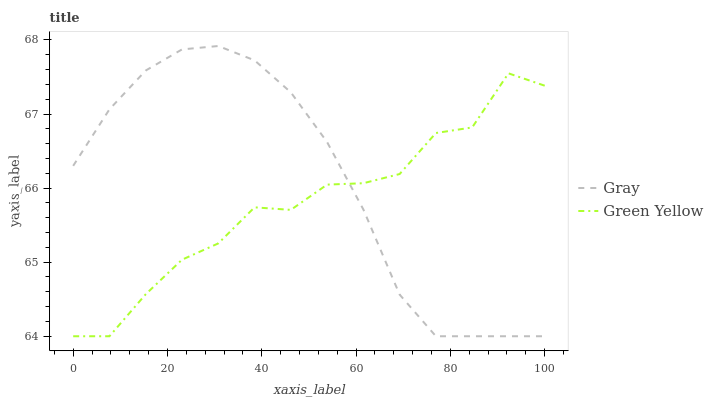Does Green Yellow have the minimum area under the curve?
Answer yes or no. Yes. Does Gray have the maximum area under the curve?
Answer yes or no. Yes. Does Green Yellow have the maximum area under the curve?
Answer yes or no. No. Is Gray the smoothest?
Answer yes or no. Yes. Is Green Yellow the roughest?
Answer yes or no. Yes. Is Green Yellow the smoothest?
Answer yes or no. No. Does Gray have the lowest value?
Answer yes or no. Yes. Does Gray have the highest value?
Answer yes or no. Yes. Does Green Yellow have the highest value?
Answer yes or no. No. Does Green Yellow intersect Gray?
Answer yes or no. Yes. Is Green Yellow less than Gray?
Answer yes or no. No. Is Green Yellow greater than Gray?
Answer yes or no. No. 